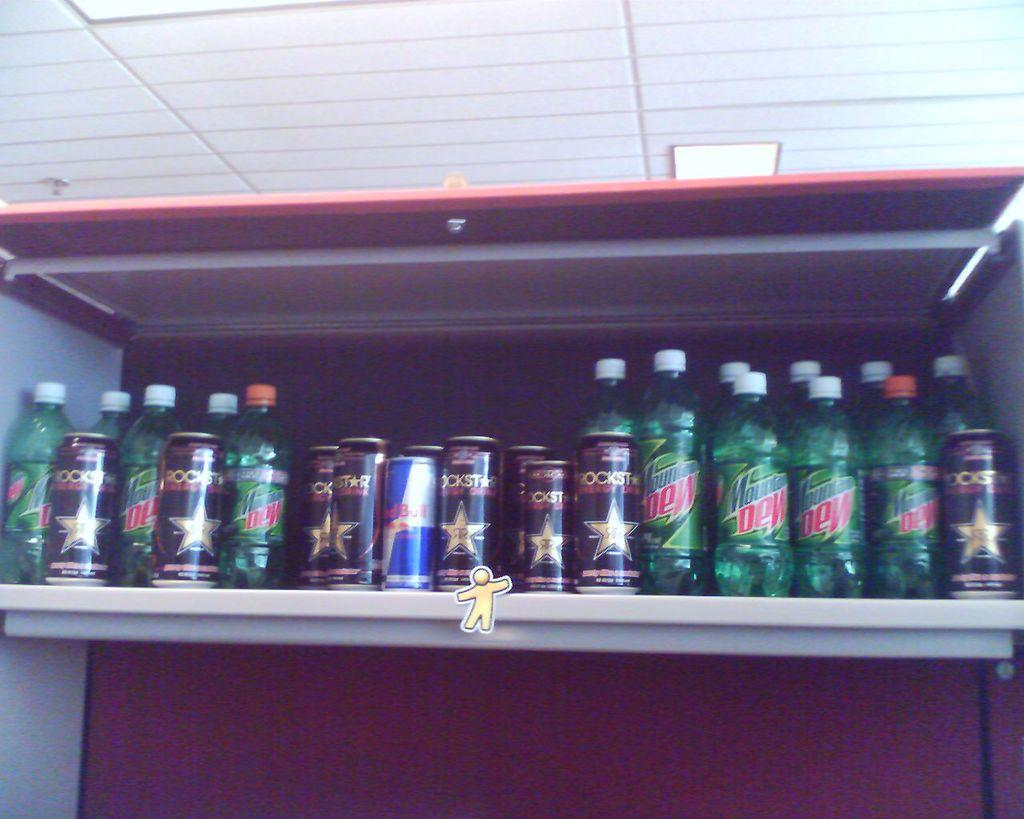<image>
Render a clear and concise summary of the photo. A shelf contains Mountain Dew, Rockstar and Red Bull. 